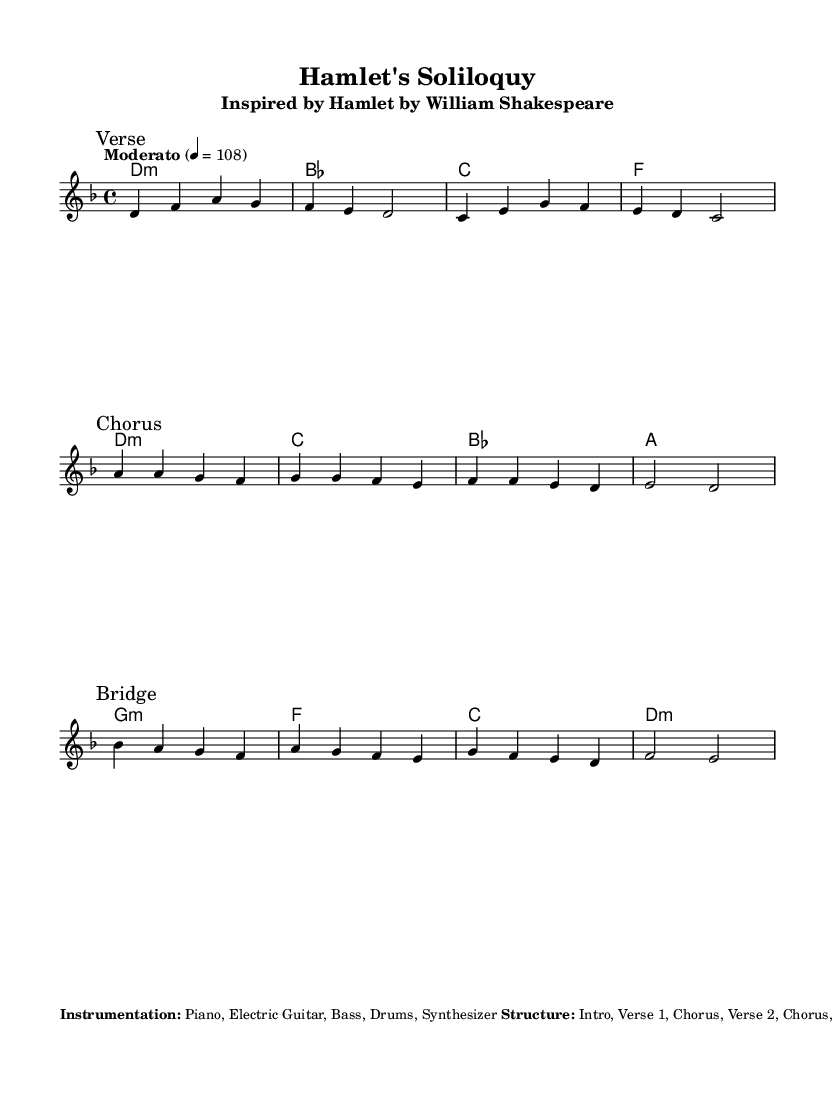What is the key signature of this music? The key signature is indicated at the start of the piece, where it shows D minor, which has one flat (B flat).
Answer: D minor What is the time signature of this music? The time signature is found near the beginning of the score, which indicates there are four beats per measure, shown as 4/4.
Answer: 4/4 What is the tempo marking for this piece? The tempo is stated clearly in the score with "Moderato" and a BPM of 108, indicating a moderate speed.
Answer: Moderato 108 How many distinct sections are there in the structure of the piece? The score notes the structure as Intro, Verse 1, Chorus, Verse 2, Chorus, Bridge, Chorus, and Outro, totaling 8 sections.
Answer: 8 What is the theme of the lyrics in this piece? The theme of the lyrics is described in the markup as dealing with existential questions and inner turmoil, inspired by Hamlet's soliloquy.
Answer: Existential questions In which part of the song does the bridge occur? By analyzing the structure, the bridge is listed after the second chorus, meaning it comes after the Verse 2 and before the final chorus.
Answer: After Verse 2 What instruments are indicated for this piece? The instrumentation is noted in the markup section, listing Piano, Electric Guitar, Bass, Drums, and Synthesizer as the instruments used.
Answer: Piano, Electric Guitar, Bass, Drums, Synthesizer 